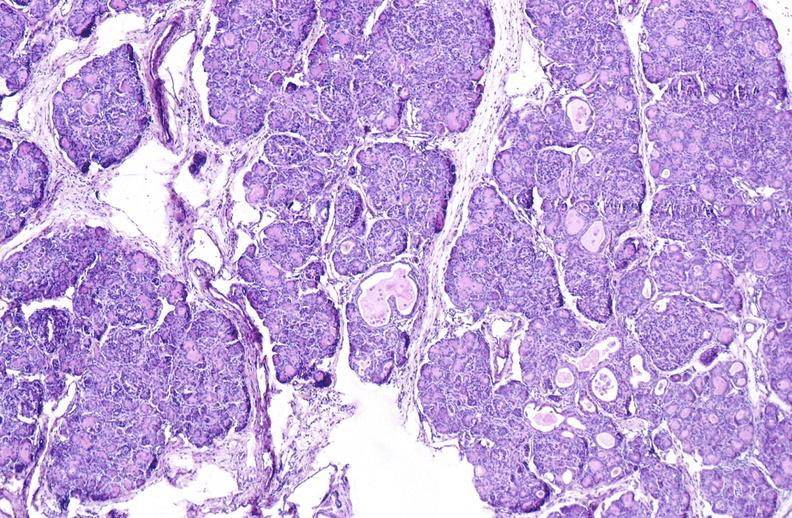what does this image show?
Answer the question using a single word or phrase. Cystic fibrosis 